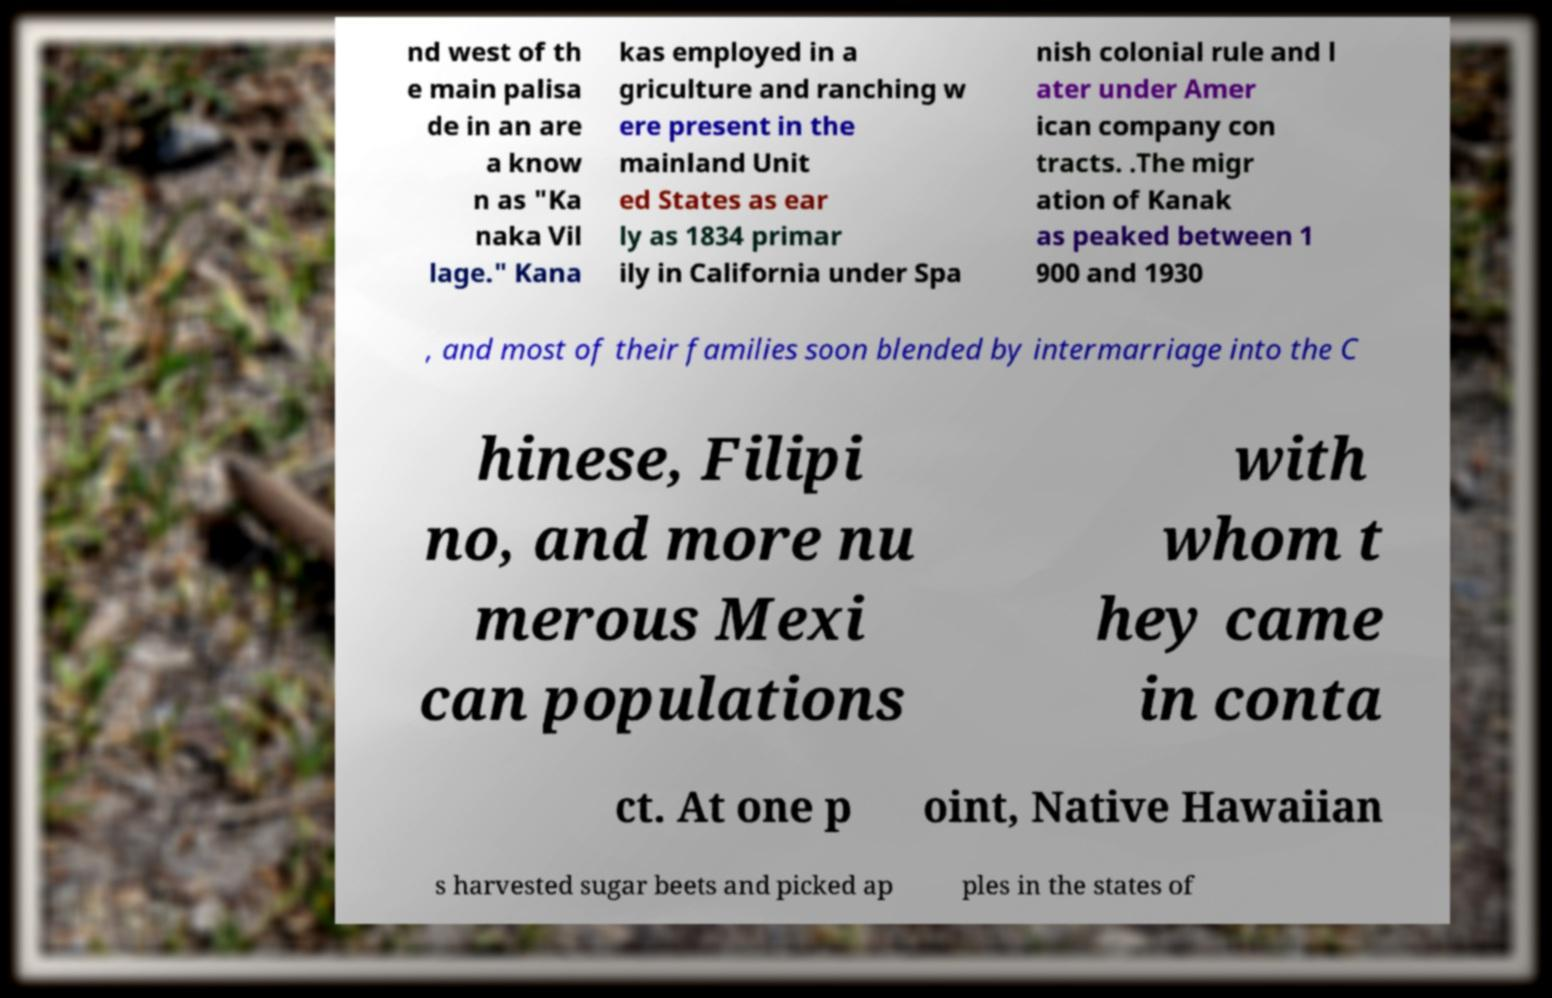What messages or text are displayed in this image? I need them in a readable, typed format. nd west of th e main palisa de in an are a know n as "Ka naka Vil lage." Kana kas employed in a griculture and ranching w ere present in the mainland Unit ed States as ear ly as 1834 primar ily in California under Spa nish colonial rule and l ater under Amer ican company con tracts. .The migr ation of Kanak as peaked between 1 900 and 1930 , and most of their families soon blended by intermarriage into the C hinese, Filipi no, and more nu merous Mexi can populations with whom t hey came in conta ct. At one p oint, Native Hawaiian s harvested sugar beets and picked ap ples in the states of 